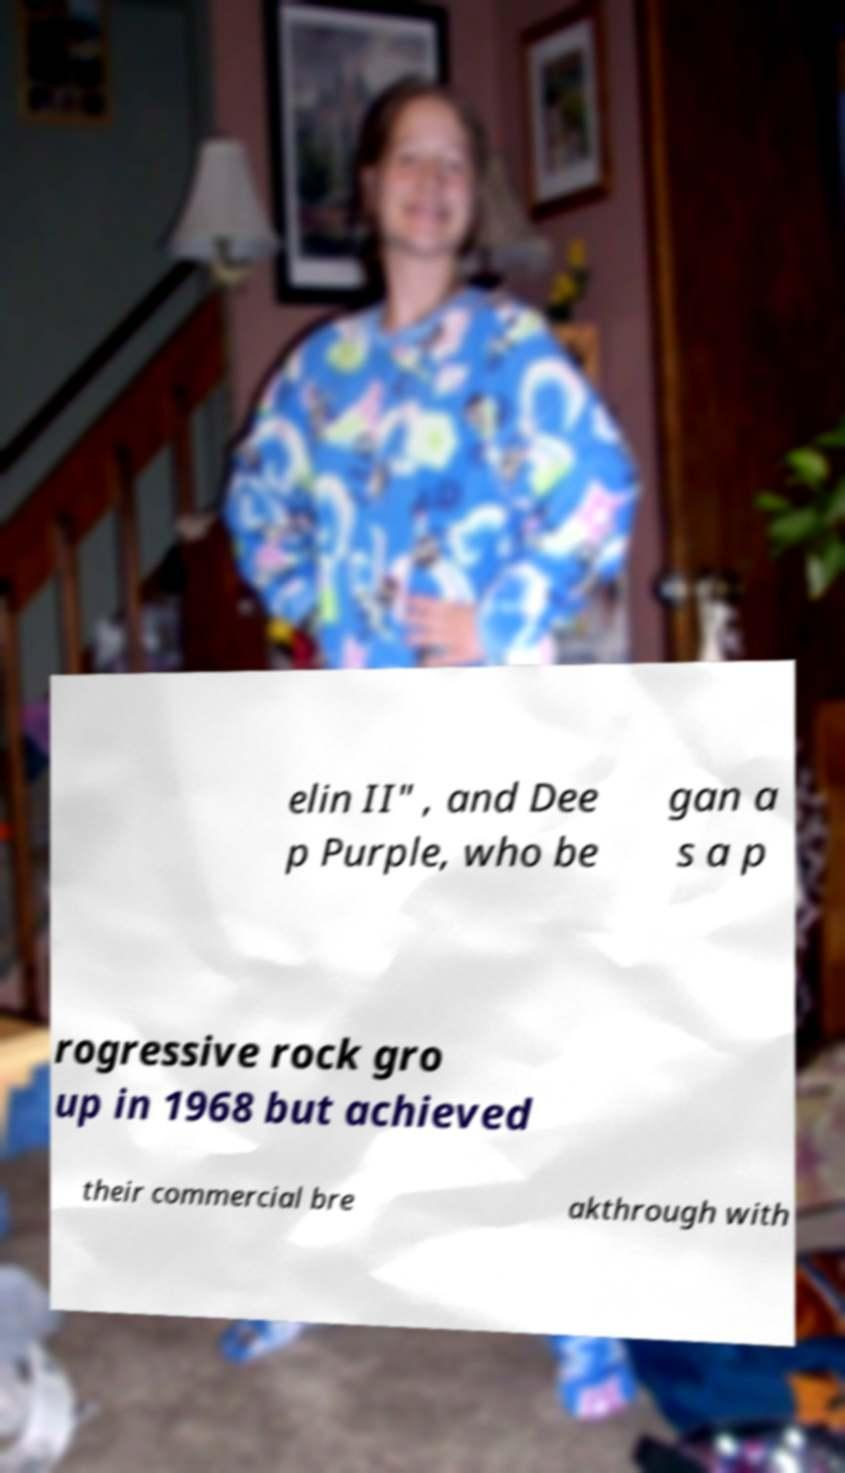Can you accurately transcribe the text from the provided image for me? elin II" , and Dee p Purple, who be gan a s a p rogressive rock gro up in 1968 but achieved their commercial bre akthrough with 